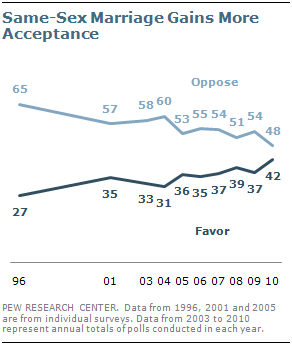Identify some key points in this picture. The rightmost value of the Oppose graph is 48. The data points in the Favor graph repeat a total of 37 times. 